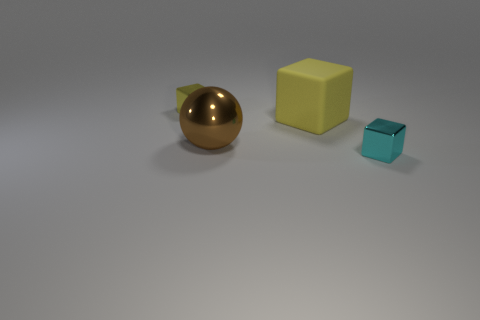What shape is the big object behind the large brown metal thing?
Offer a terse response. Cube. The yellow object that is made of the same material as the big sphere is what size?
Keep it short and to the point. Small. What number of other matte objects are the same shape as the small yellow thing?
Your response must be concise. 1. Do the block that is left of the big yellow matte thing and the large matte cube have the same color?
Provide a short and direct response. Yes. There is a shiny block that is in front of the small metal thing that is on the left side of the tiny cyan object; what number of small objects are to the left of it?
Ensure brevity in your answer.  1. What number of things are behind the sphere and to the right of the sphere?
Make the answer very short. 1. There is a metallic object that is the same color as the rubber object; what is its shape?
Make the answer very short. Cube. Is there anything else that is the same material as the brown object?
Offer a very short reply. Yes. Is the brown thing made of the same material as the small cyan cube?
Your answer should be very brief. Yes. There is a brown metal object that is to the right of the metal block left of the small block to the right of the large yellow matte object; what shape is it?
Make the answer very short. Sphere. 